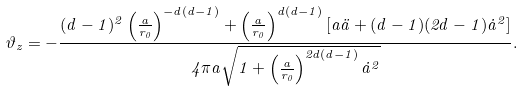Convert formula to latex. <formula><loc_0><loc_0><loc_500><loc_500>\vartheta _ { z } = - \frac { ( d - 1 ) ^ { 2 } \left ( \frac { a } { r _ { 0 } } \right ) ^ { - d ( d - 1 ) } + \left ( \frac { a } { r _ { 0 } } \right ) ^ { d ( d - 1 ) } [ a \ddot { a } + ( d - 1 ) ( 2 d - 1 ) \dot { a } ^ { 2 } ] } { 4 \pi a \sqrt { 1 + \left ( \frac { a } { r _ { 0 } } \right ) ^ { 2 d ( d - 1 ) } \dot { a } ^ { 2 } } } .</formula> 